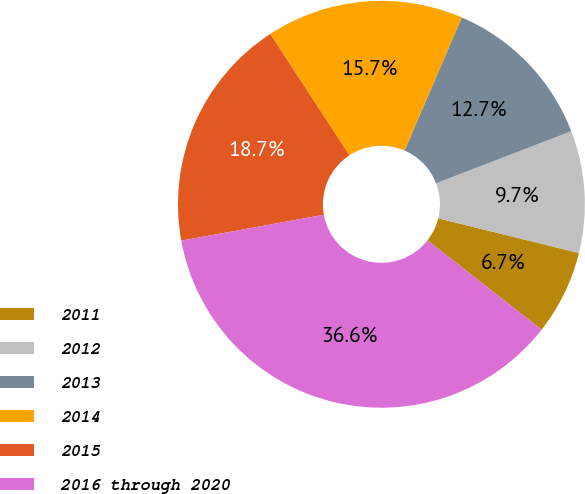<chart> <loc_0><loc_0><loc_500><loc_500><pie_chart><fcel>2011<fcel>2012<fcel>2013<fcel>2014<fcel>2015<fcel>2016 through 2020<nl><fcel>6.72%<fcel>9.7%<fcel>12.69%<fcel>15.67%<fcel>18.66%<fcel>36.57%<nl></chart> 